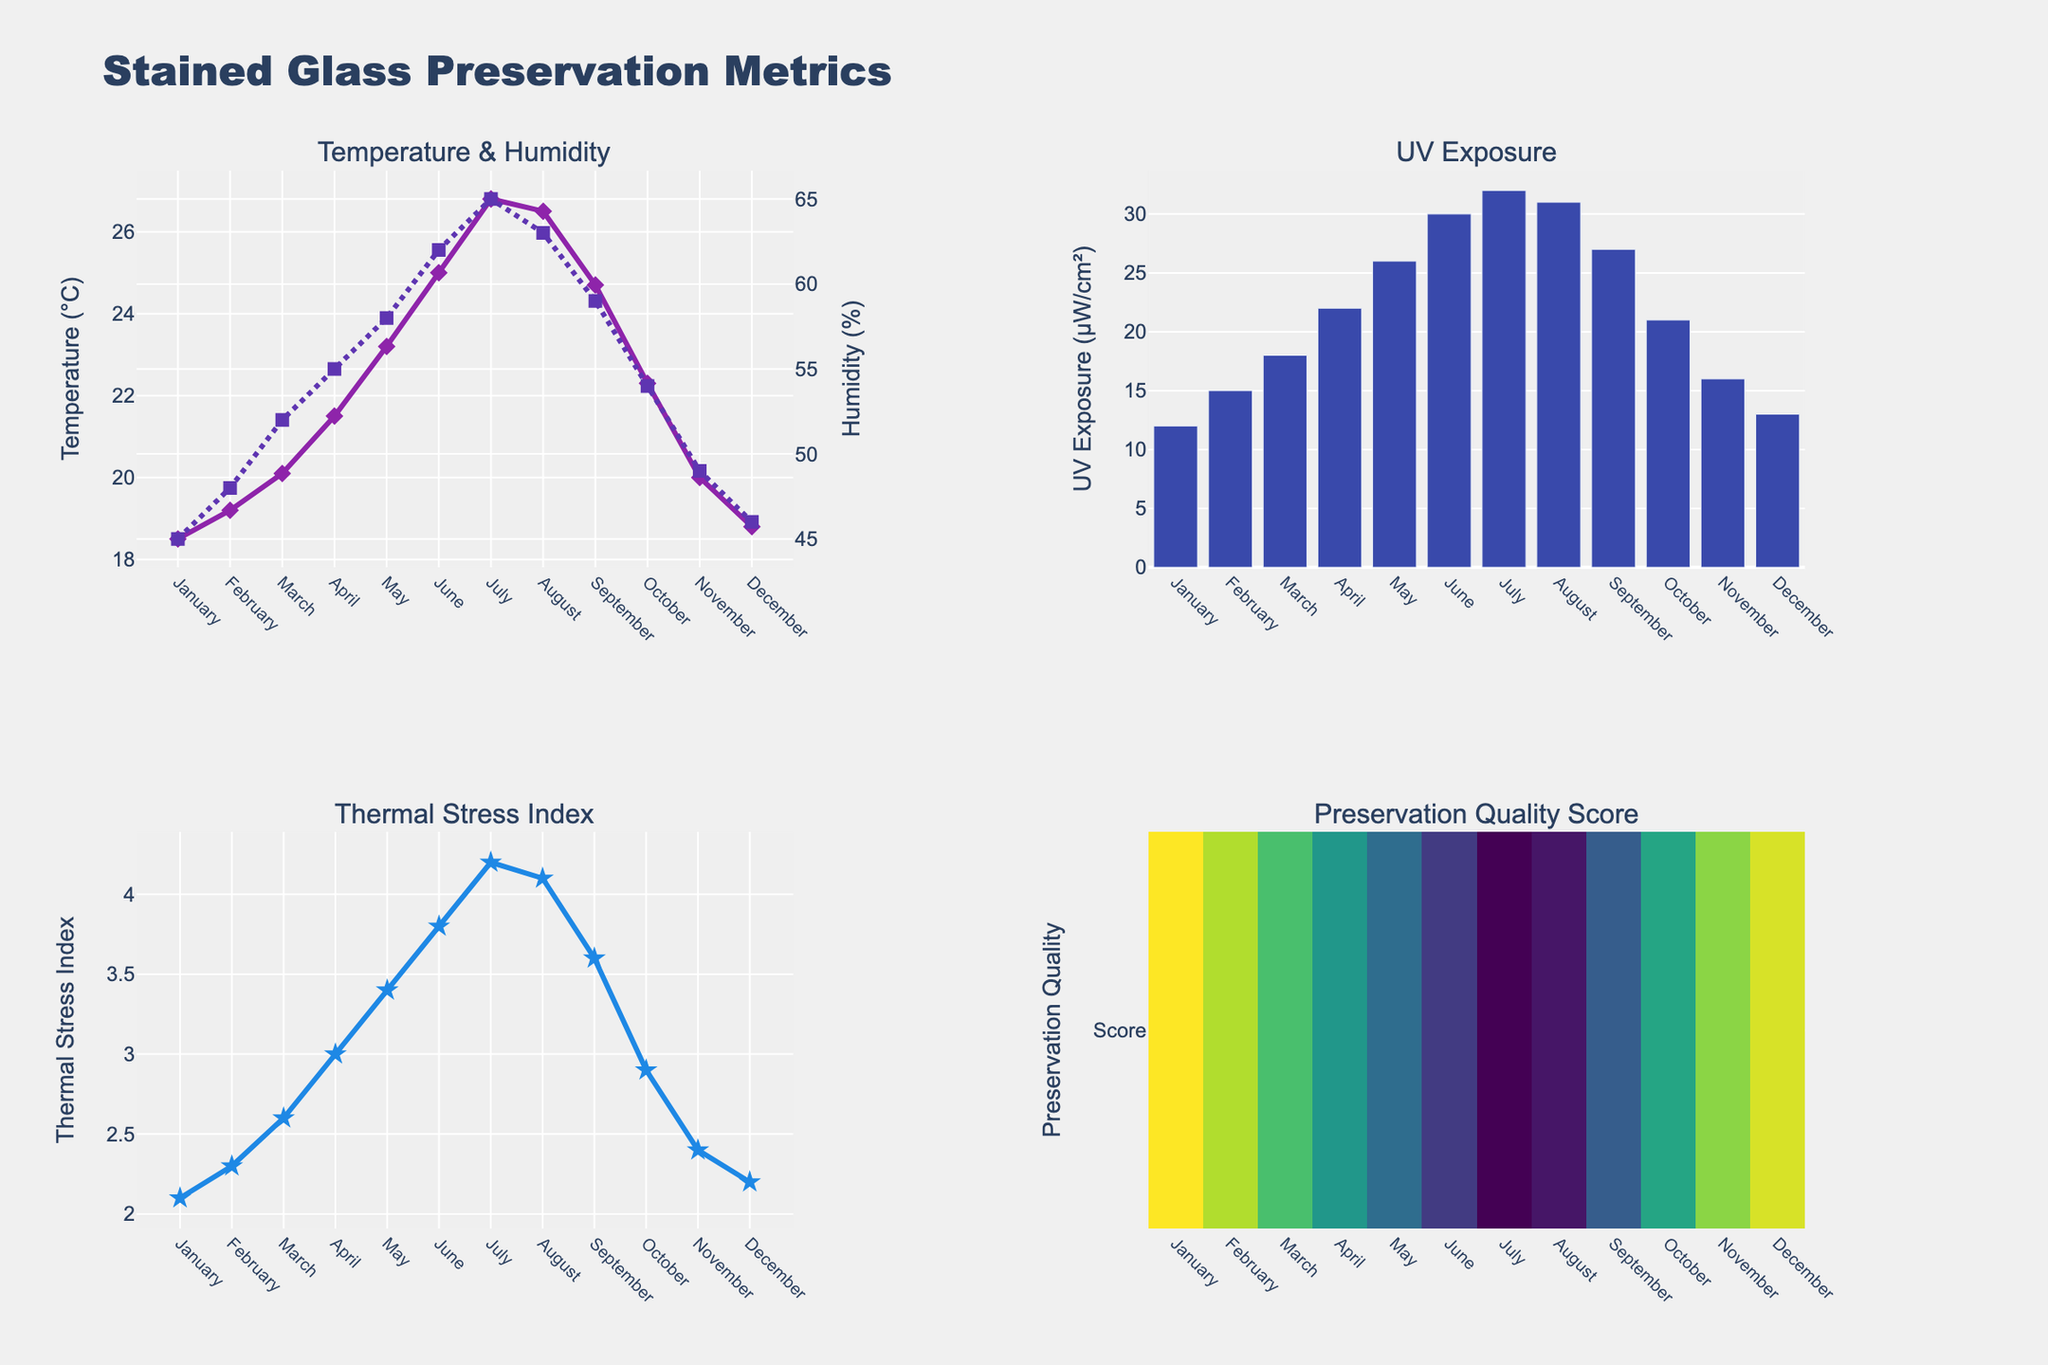How does the temperature vary throughout the year? Observe the "Temperature & Humidity" subplot, particularly the line representing Average Temperature in °C. You'll notice that the temperature increases each month from January to July, peaking at 26.8°C in July, and then gradually decreases each month until December, where it is 18.8°C.
Answer: It peaks in July and is lowest in January What is the trend between UV Exposure and months? In the "UV Exposure" subplot, bar heights progressively increase from January, peaking around June and July, and then decrease back towards December, maintaining a roughly symmetrical pattern year-round.
Answer: Peaks in June and July, lower in winter months Which month recorded the highest Preservation Quality Score? Look at the "Preservation Quality Score" heatmap in the bottom right. The darker the color, the higher the score. You can see that January, represented by the darkest square, has the highest Preservation Quality Score.
Answer: January What is the relationship between Thermal Stress Index and months? In the "Thermal Stress Index" subplot, observe how the line with markers changes month to month. The Thermal Stress Index starts low in January, progressively increases to a high in July and August, and then decreases again towards December.
Answer: Increases to a peak in July and then decreases Which month shows the highest humidity levels? Referring to the "Temperature & Humidity" subplot, observe the dashed line representing humidity levels. The highest point of this line is in July, indicating the highest humidity level.
Answer: July How does the Preservation Quality Score change as the Thermal Stress Index increases? By examining both the "Preservation Quality Score" heatmap and "Thermal Stress Index" line plot, one can make a logical connection. As the Thermal Stress Index rises from January to July, the Preservation Quality Score declines from 8.7 to 7.0, indicating a negative relationship between thermal stress and preservation quality.
Answer: Decreases Compare the Average Temperature and UV Exposure in March and October. Look at the relevant subplots. For March, Average Temperature is 20.1°C and UV Exposure is 18 μW/cm²; for October, Average Temperature is 22.3°C and UV Exposure is 21 μW/cm². Thus, both temperature and UV Exposure are higher in October compared to March.
Answer: Higher in October What is the preservation quality score in the month with the highest UV exposure? The "UV Exposure" subplot shows the highest exposure in June and July. Refer to the "Preservation Quality Score" heatmap, where June and July have scores of 7.3 and 7.0, respectively. Hence, the score for June (the first peak) is 7.3.
Answer: 7.3 How is the yearly trend of humidity levels? By examining the dashed line in the "Temperature & Humidity" subplot, observe that the humidity starts at around 45% in January, increases to its peak at 65% in July, and decreases again towards December.
Answer: Increases to a peak in July and then decreases 